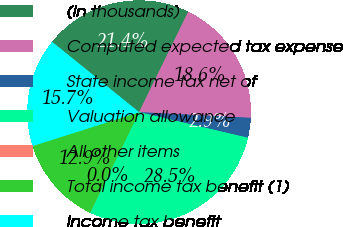Convert chart to OTSL. <chart><loc_0><loc_0><loc_500><loc_500><pie_chart><fcel>(in thousands)<fcel>Computed expected tax expense<fcel>State income tax net of<fcel>Valuation allowance<fcel>All other items<fcel>Total income tax benefit (1)<fcel>Income tax benefit<nl><fcel>21.42%<fcel>18.57%<fcel>2.87%<fcel>28.53%<fcel>0.02%<fcel>12.87%<fcel>15.72%<nl></chart> 